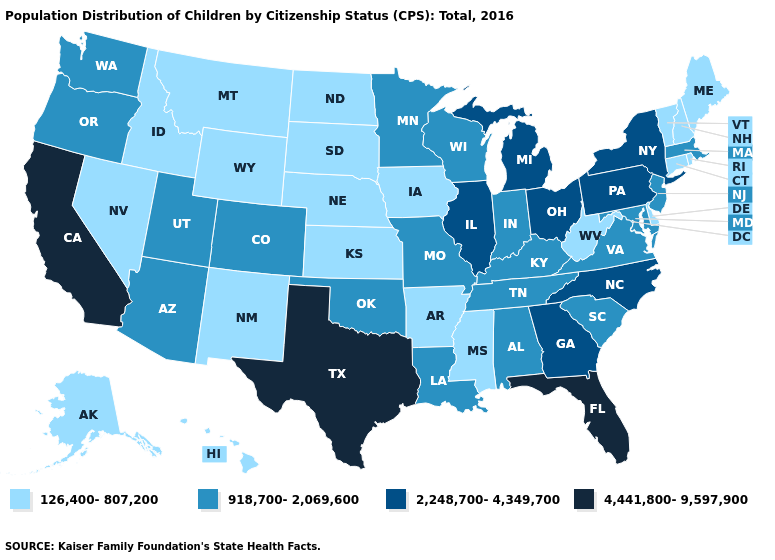Among the states that border Minnesota , which have the lowest value?
Be succinct. Iowa, North Dakota, South Dakota. How many symbols are there in the legend?
Answer briefly. 4. What is the highest value in states that border Arizona?
Concise answer only. 4,441,800-9,597,900. Among the states that border New Hampshire , does Massachusetts have the lowest value?
Quick response, please. No. Name the states that have a value in the range 126,400-807,200?
Short answer required. Alaska, Arkansas, Connecticut, Delaware, Hawaii, Idaho, Iowa, Kansas, Maine, Mississippi, Montana, Nebraska, Nevada, New Hampshire, New Mexico, North Dakota, Rhode Island, South Dakota, Vermont, West Virginia, Wyoming. What is the value of Missouri?
Short answer required. 918,700-2,069,600. Among the states that border Iowa , which have the highest value?
Write a very short answer. Illinois. What is the value of Alabama?
Concise answer only. 918,700-2,069,600. What is the value of Rhode Island?
Answer briefly. 126,400-807,200. Name the states that have a value in the range 4,441,800-9,597,900?
Be succinct. California, Florida, Texas. Does Utah have the lowest value in the West?
Quick response, please. No. Which states have the highest value in the USA?
Quick response, please. California, Florida, Texas. Name the states that have a value in the range 4,441,800-9,597,900?
Be succinct. California, Florida, Texas. Does Wyoming have the lowest value in the West?
Keep it brief. Yes. Which states hav the highest value in the MidWest?
Answer briefly. Illinois, Michigan, Ohio. 